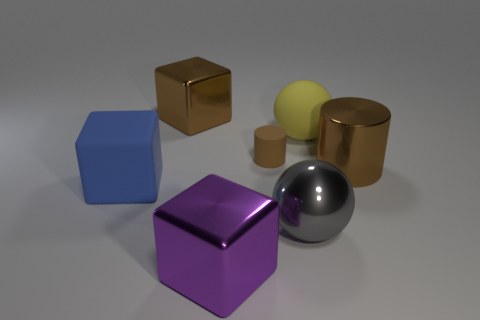Are there any other things that have the same size as the matte cylinder?
Your answer should be compact. No. Is the size of the rubber block the same as the cylinder that is left of the yellow rubber object?
Provide a succinct answer. No. Is the number of brown metal cylinders behind the matte ball less than the number of purple metal things?
Make the answer very short. Yes. How many metallic cubes have the same color as the tiny rubber thing?
Your answer should be compact. 1. Are there fewer blue rubber cubes than small green things?
Keep it short and to the point. No. Do the blue block and the small brown thing have the same material?
Your response must be concise. Yes. How many other things are there of the same size as the matte cylinder?
Give a very brief answer. 0. What color is the object on the left side of the big metal block that is behind the big yellow matte ball?
Your answer should be compact. Blue. What number of other objects are the same shape as the small thing?
Provide a short and direct response. 1. Are there any big objects that have the same material as the brown cube?
Your answer should be very brief. Yes. 